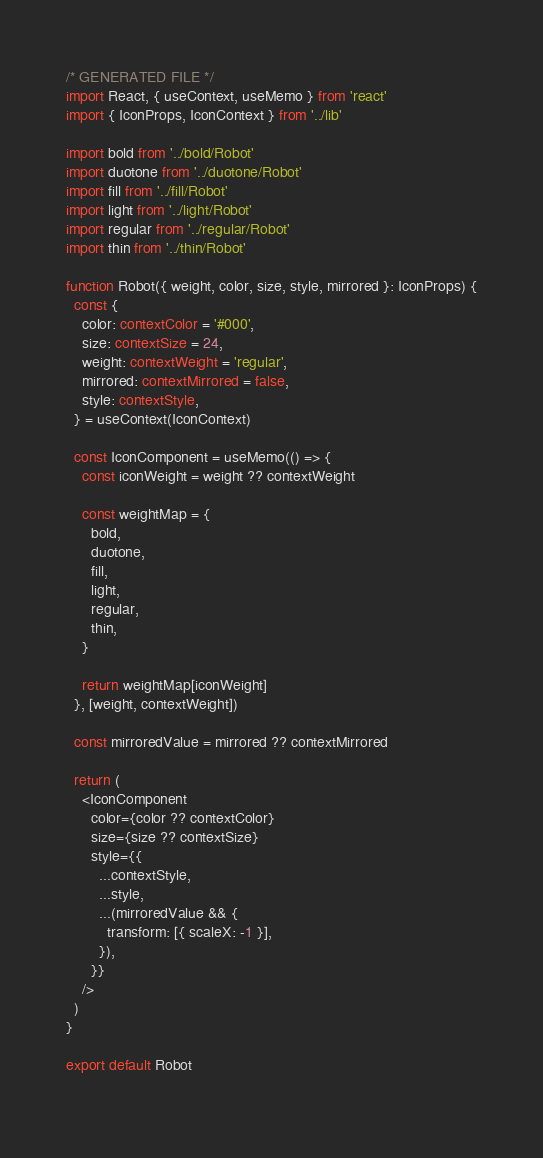<code> <loc_0><loc_0><loc_500><loc_500><_TypeScript_>/* GENERATED FILE */
import React, { useContext, useMemo } from 'react'
import { IconProps, IconContext } from '../lib'

import bold from '../bold/Robot'
import duotone from '../duotone/Robot'
import fill from '../fill/Robot'
import light from '../light/Robot'
import regular from '../regular/Robot'
import thin from '../thin/Robot'

function Robot({ weight, color, size, style, mirrored }: IconProps) {
  const {
    color: contextColor = '#000',
    size: contextSize = 24,
    weight: contextWeight = 'regular',
    mirrored: contextMirrored = false, 
    style: contextStyle,
  } = useContext(IconContext)

  const IconComponent = useMemo(() => {
    const iconWeight = weight ?? contextWeight

    const weightMap = {
      bold,
      duotone,
      fill,
      light,
      regular,
      thin,
    }

    return weightMap[iconWeight]
  }, [weight, contextWeight])

  const mirroredValue = mirrored ?? contextMirrored

  return (
    <IconComponent
      color={color ?? contextColor}
      size={size ?? contextSize}
      style={{
        ...contextStyle,
        ...style,
        ...(mirroredValue && {
          transform: [{ scaleX: -1 }],
        }),
      }}
    />
  )
}

export default Robot
  </code> 